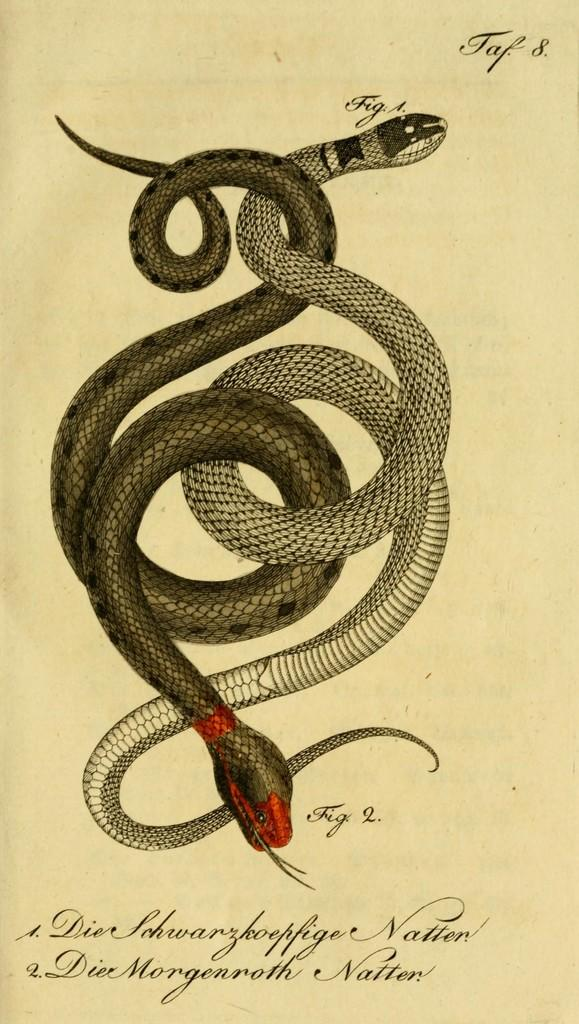What type of animals are depicted in the image? There are depictions of snakes in the image. What else can be seen in the image besides the snakes? There is text on a paper in the image. How many fingers are visible in the image? There are no fingers visible in the image; it only contains depictions of snakes and text on a paper. 